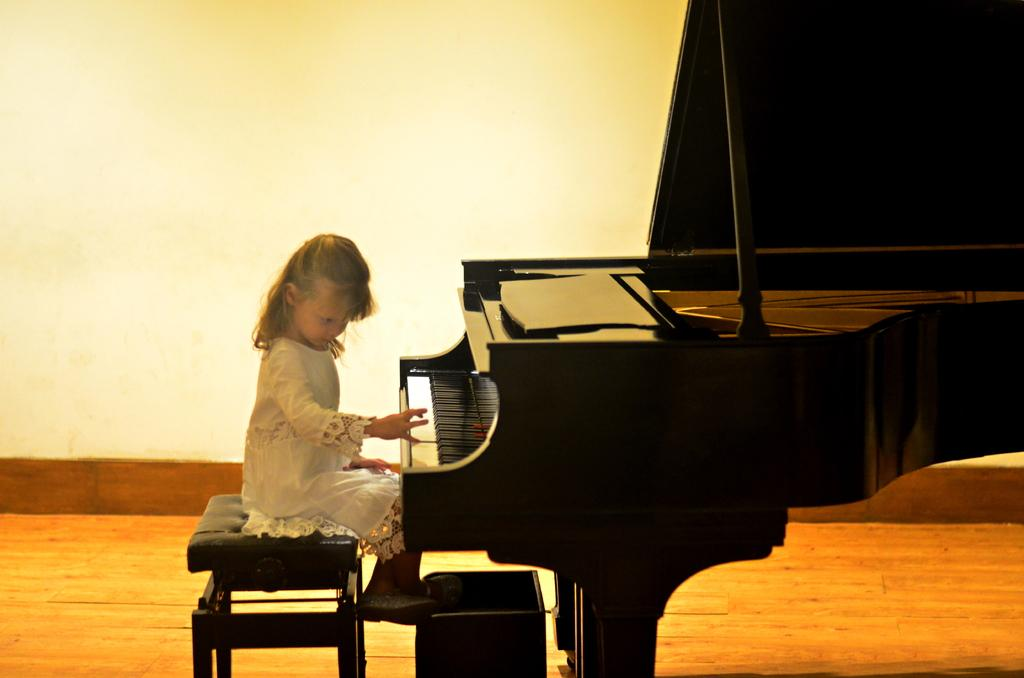Who is the main subject in the image? There is a girl in the image. What is the girl doing in the image? The girl is sitting on a chair and playing a piano. What can be seen in the background of the image? There is a wall in the background of the image. What is the surface beneath the girl's feet in the image? There is a floor visible in the image. What type of meal is the girl preparing on the building in the image? There is no building or meal preparation visible in the image; it features a girl playing a piano. What kind of brush is the girl using to paint the wall in the image? There is no brush or painting activity visible in the image; the girl is playing a piano. 